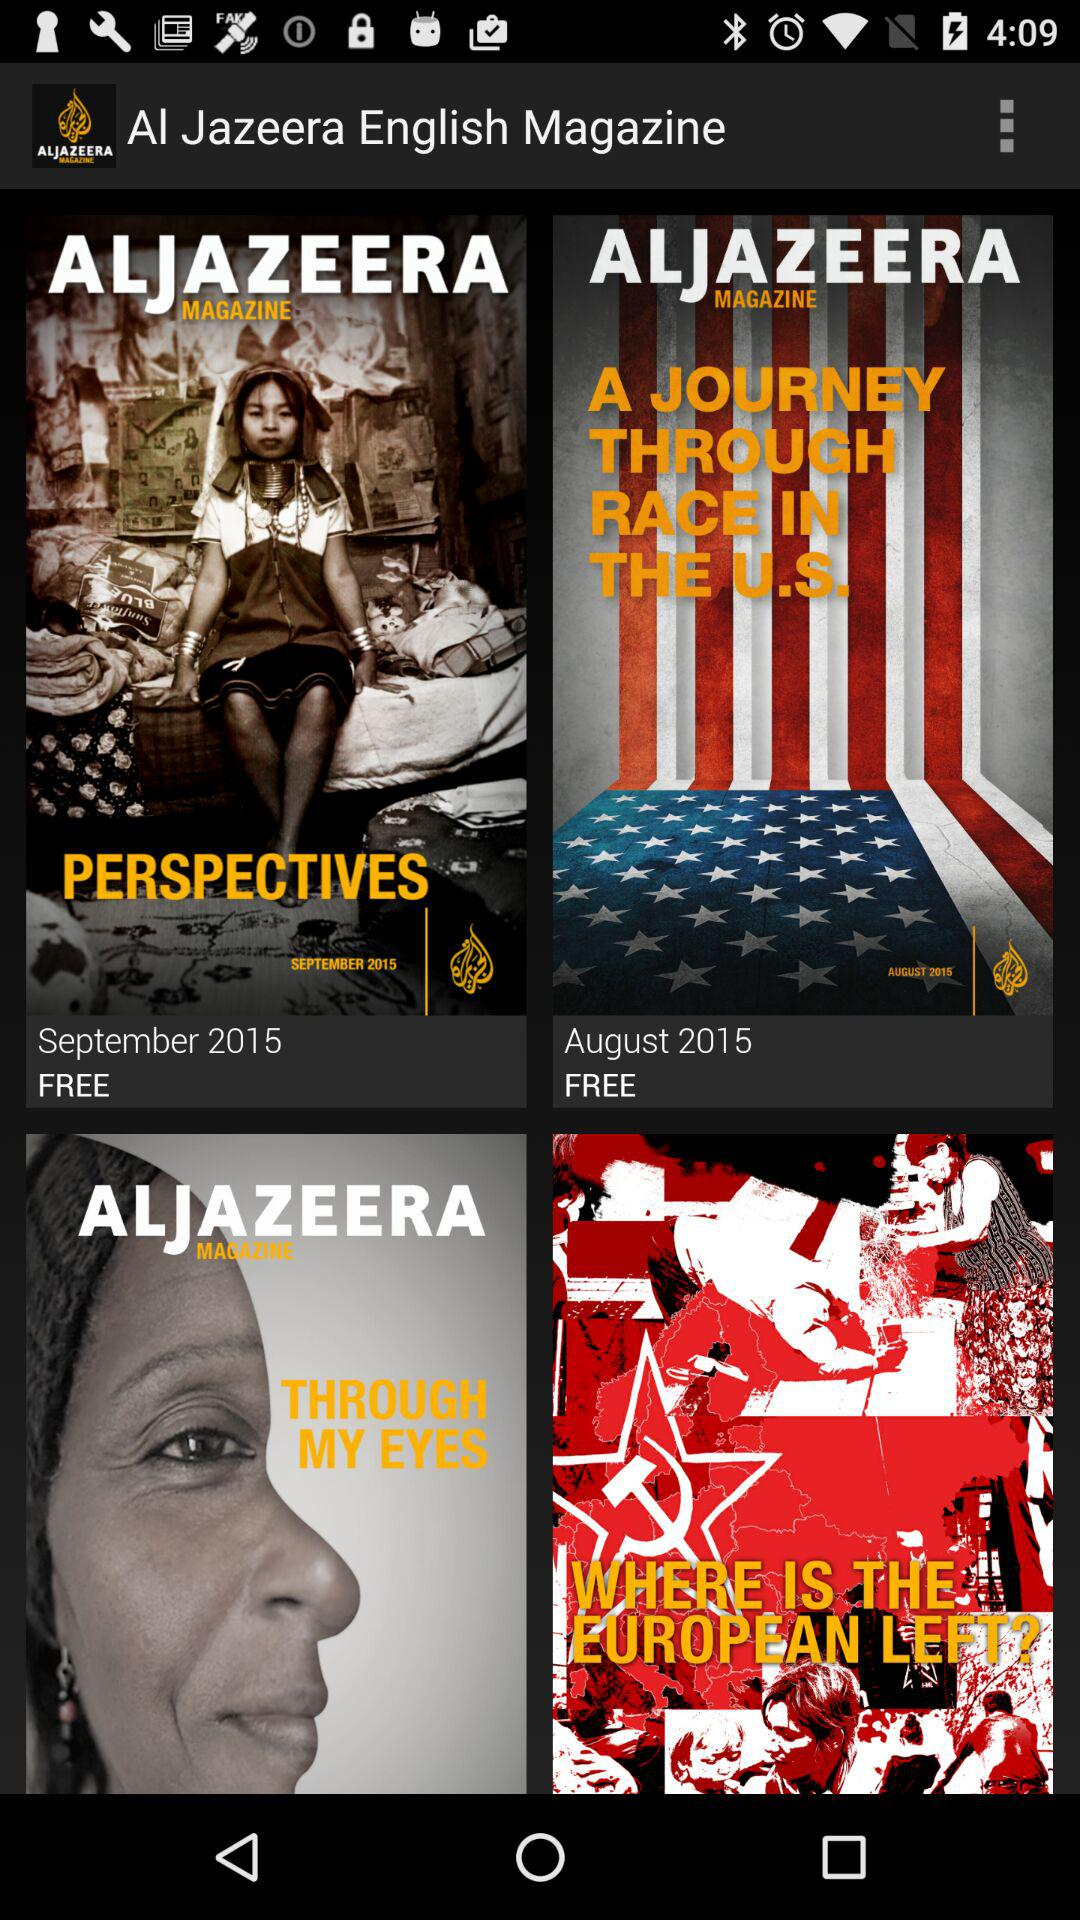What is the price of "A JOURNEY THROUGH RACE IN THE U.S."? The price of "A JOURNEY THROUGH RACE IN THE U.S." is free. 